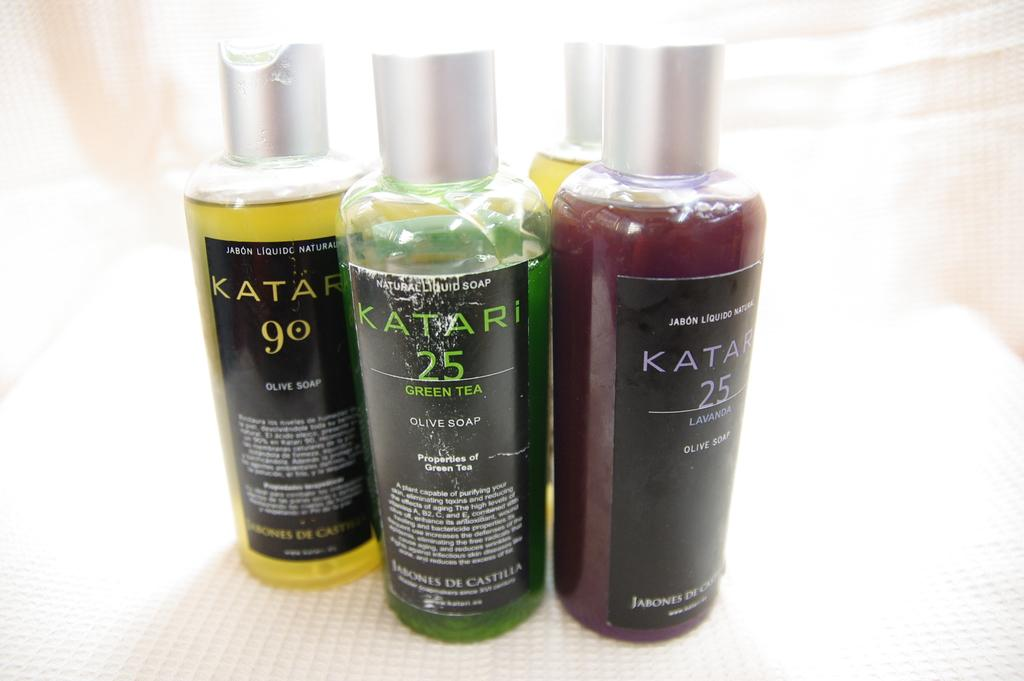<image>
Present a compact description of the photo's key features. Several bottles of different colored Katari olive soap are grouped together. 